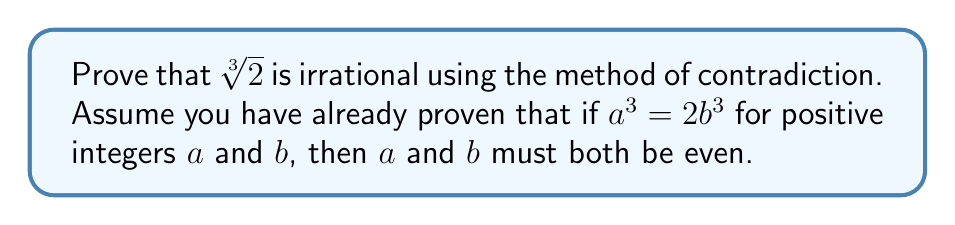Show me your answer to this math problem. Let's prove this step-by-step using contradiction:

1) Assume, for the sake of contradiction, that $\sqrt[3]{2}$ is rational.

2) If $\sqrt[3]{2}$ is rational, it can be expressed as a fraction $\frac{a}{b}$ where $a$ and $b$ are positive integers with no common factors:

   $$\sqrt[3]{2} = \frac{a}{b}$$

3) Cube both sides:

   $$(\sqrt[3]{2})^3 = (\frac{a}{b})^3$$

4) Simplify:

   $$2 = \frac{a^3}{b^3}$$

5) Multiply both sides by $b^3$:

   $$2b^3 = a^3$$

6) From the given information, we know that if $a^3 = 2b^3$ for positive integers $a$ and $b$, then $a$ and $b$ must both be even.

7) If $a$ is even, we can write $a = 2k$ for some integer $k$. Substituting this into the equation from step 5:

   $$2b^3 = (2k)^3 = 8k^3$$

8) Divide both sides by 2:

   $$b^3 = 4k^3$$

9) This implies that $b^3$ is even, which means $b$ must be even.

10) However, if both $a$ and $b$ are even, they have a common factor of 2, which contradicts our initial assumption that $a$ and $b$ have no common factors.

11) This contradiction proves that our initial assumption (that $\sqrt[3]{2}$ is rational) must be false.

Therefore, $\sqrt[3]{2}$ is irrational.
Answer: $\sqrt[3]{2}$ is irrational. 